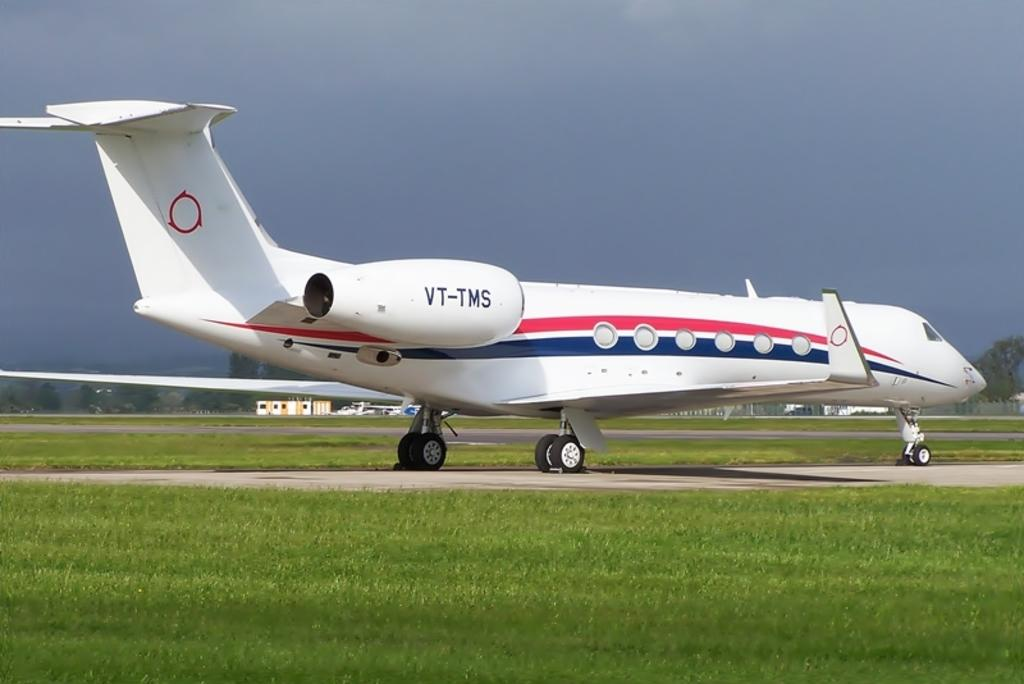<image>
Render a clear and concise summary of the photo. A private jet with the number VT-TMS is sitting on a runway. 